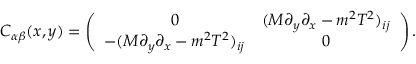<formula> <loc_0><loc_0><loc_500><loc_500>C _ { \alpha \beta } ( x , y ) = \left ( \begin{array} { c c } { 0 } & { { ( M \partial _ { y } \partial _ { x } - m ^ { 2 } T ^ { 2 } ) _ { i j } } } \\ { { - ( M \partial _ { y } \partial _ { x } - m ^ { 2 } T ^ { 2 } ) _ { i j } } } & { 0 } \end{array} \right ) .</formula> 